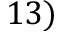Convert formula to latex. <formula><loc_0><loc_0><loc_500><loc_500>1 3 )</formula> 